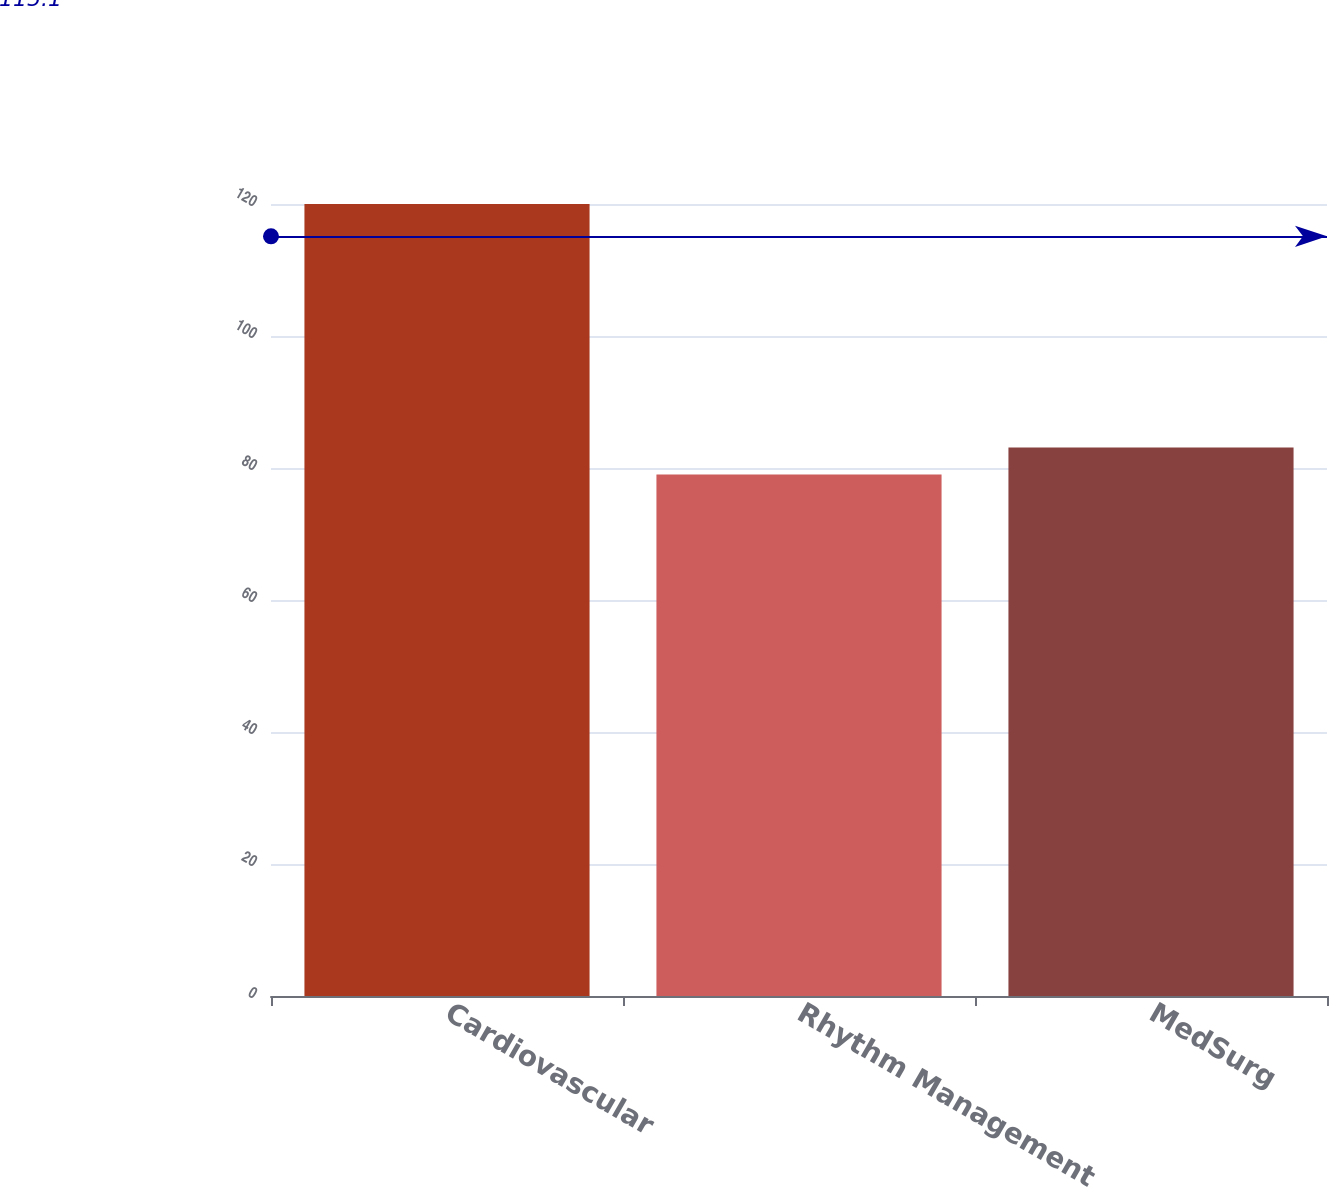Convert chart to OTSL. <chart><loc_0><loc_0><loc_500><loc_500><bar_chart><fcel>Cardiovascular<fcel>Rhythm Management<fcel>MedSurg<nl><fcel>120<fcel>79<fcel>83.1<nl></chart> 